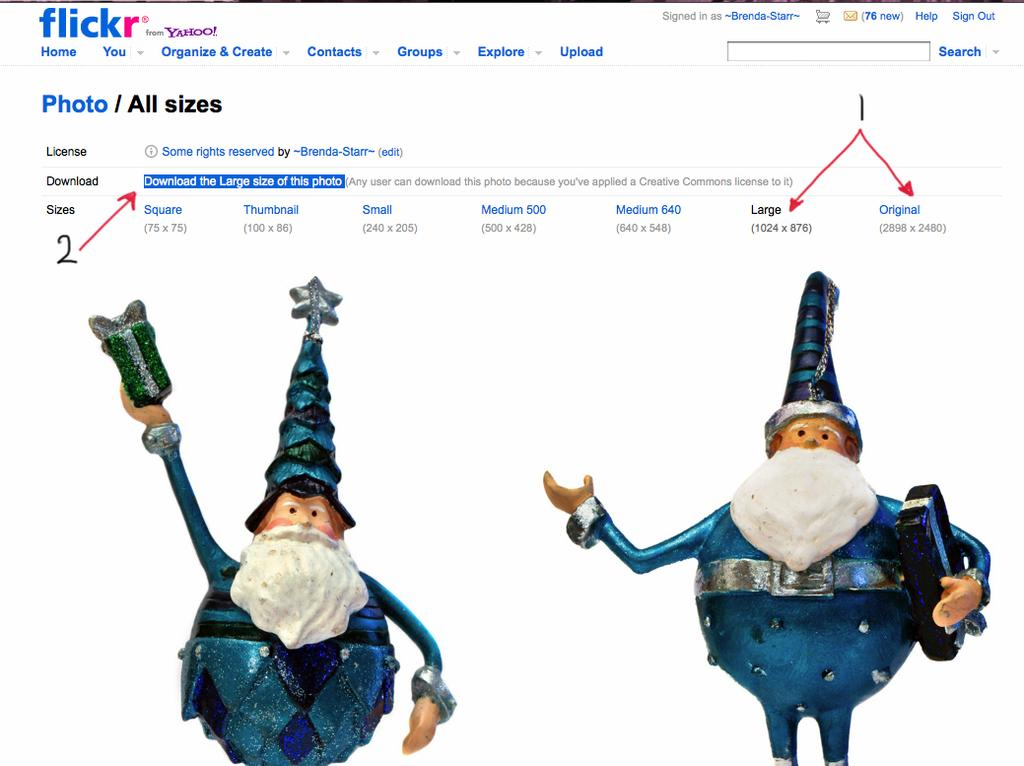What is the main subject of the image? The main subject of the image is a page. What can be found on the page? The page contains toys. What is written or visible at the top of the image? There is text visible at the top of the image. Are there any symbols or indicators on the page? Yes, there are arrows visible at the top of the image. What is the purpose of the crowd in the image? There is no crowd present in the image; it only features a page with toys, text, and arrows. 